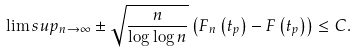Convert formula to latex. <formula><loc_0><loc_0><loc_500><loc_500>\lim s u p _ { n \rightarrow \infty } \pm \sqrt { \frac { n } { \log \log n } } \left ( F _ { n } \left ( t _ { p } \right ) - F \left ( t _ { p } \right ) \right ) \leq C .</formula> 